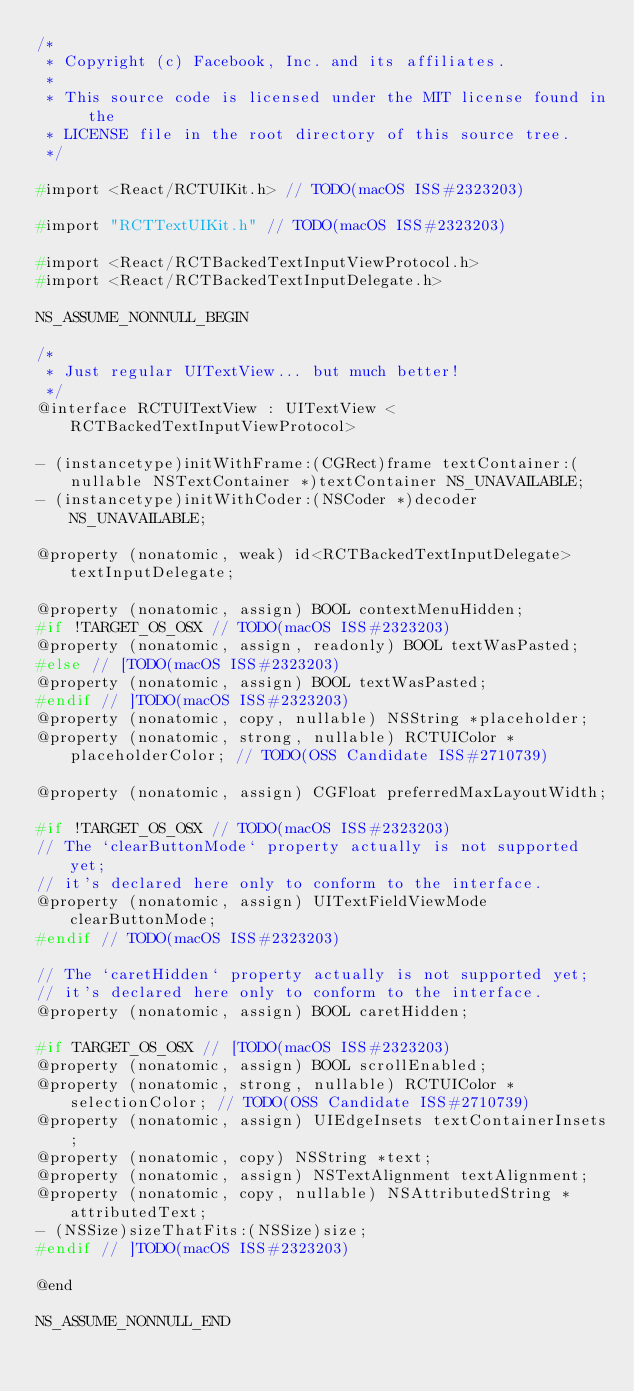<code> <loc_0><loc_0><loc_500><loc_500><_C_>/*
 * Copyright (c) Facebook, Inc. and its affiliates.
 *
 * This source code is licensed under the MIT license found in the
 * LICENSE file in the root directory of this source tree.
 */

#import <React/RCTUIKit.h> // TODO(macOS ISS#2323203)

#import "RCTTextUIKit.h" // TODO(macOS ISS#2323203)

#import <React/RCTBackedTextInputViewProtocol.h>
#import <React/RCTBackedTextInputDelegate.h>

NS_ASSUME_NONNULL_BEGIN

/*
 * Just regular UITextView... but much better!
 */
@interface RCTUITextView : UITextView <RCTBackedTextInputViewProtocol>

- (instancetype)initWithFrame:(CGRect)frame textContainer:(nullable NSTextContainer *)textContainer NS_UNAVAILABLE;
- (instancetype)initWithCoder:(NSCoder *)decoder NS_UNAVAILABLE;

@property (nonatomic, weak) id<RCTBackedTextInputDelegate> textInputDelegate;

@property (nonatomic, assign) BOOL contextMenuHidden;
#if !TARGET_OS_OSX // TODO(macOS ISS#2323203)
@property (nonatomic, assign, readonly) BOOL textWasPasted;
#else // [TODO(macOS ISS#2323203)
@property (nonatomic, assign) BOOL textWasPasted;
#endif // ]TODO(macOS ISS#2323203)
@property (nonatomic, copy, nullable) NSString *placeholder;
@property (nonatomic, strong, nullable) RCTUIColor *placeholderColor; // TODO(OSS Candidate ISS#2710739)

@property (nonatomic, assign) CGFloat preferredMaxLayoutWidth;

#if !TARGET_OS_OSX // TODO(macOS ISS#2323203)
// The `clearButtonMode` property actually is not supported yet;
// it's declared here only to conform to the interface.
@property (nonatomic, assign) UITextFieldViewMode clearButtonMode;
#endif // TODO(macOS ISS#2323203)

// The `caretHidden` property actually is not supported yet;
// it's declared here only to conform to the interface.
@property (nonatomic, assign) BOOL caretHidden;

#if TARGET_OS_OSX // [TODO(macOS ISS#2323203)
@property (nonatomic, assign) BOOL scrollEnabled;
@property (nonatomic, strong, nullable) RCTUIColor *selectionColor; // TODO(OSS Candidate ISS#2710739)
@property (nonatomic, assign) UIEdgeInsets textContainerInsets;
@property (nonatomic, copy) NSString *text;
@property (nonatomic, assign) NSTextAlignment textAlignment;
@property (nonatomic, copy, nullable) NSAttributedString *attributedText;
- (NSSize)sizeThatFits:(NSSize)size;
#endif // ]TODO(macOS ISS#2323203)

@end

NS_ASSUME_NONNULL_END
</code> 